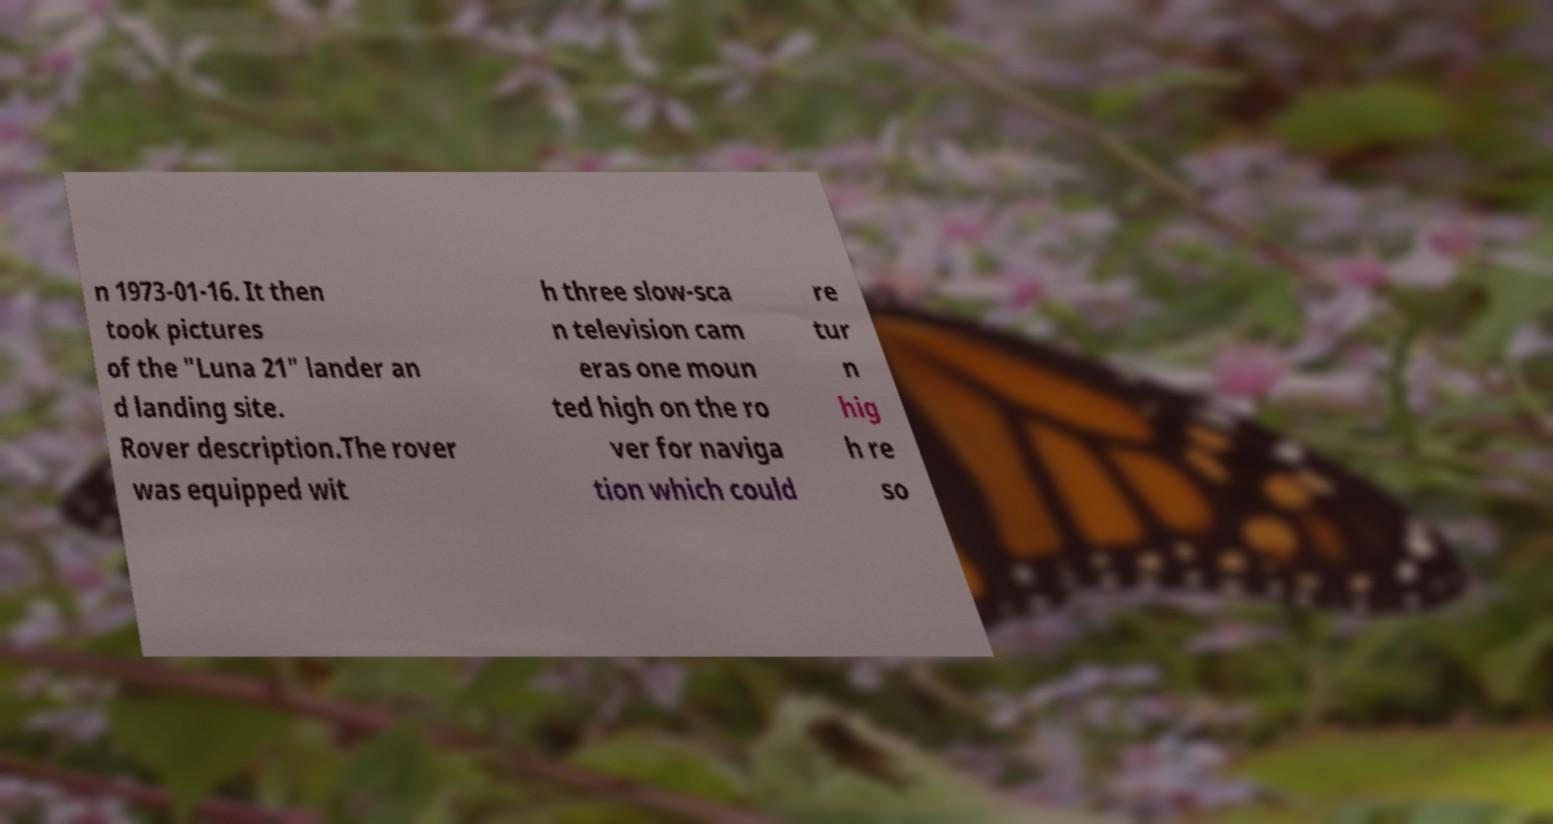Can you read and provide the text displayed in the image?This photo seems to have some interesting text. Can you extract and type it out for me? n 1973-01-16. It then took pictures of the "Luna 21" lander an d landing site. Rover description.The rover was equipped wit h three slow-sca n television cam eras one moun ted high on the ro ver for naviga tion which could re tur n hig h re so 